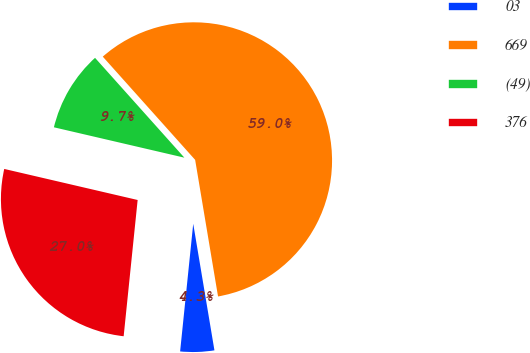Convert chart to OTSL. <chart><loc_0><loc_0><loc_500><loc_500><pie_chart><fcel>03<fcel>669<fcel>(49)<fcel>376<nl><fcel>4.27%<fcel>58.97%<fcel>9.74%<fcel>27.01%<nl></chart> 